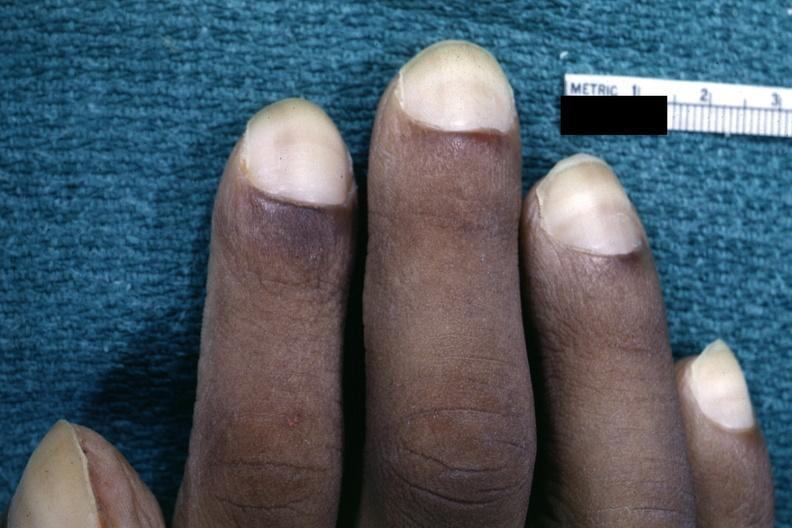does this image show close-up view of pulmonary osteoarthropathy?
Answer the question using a single word or phrase. Yes 